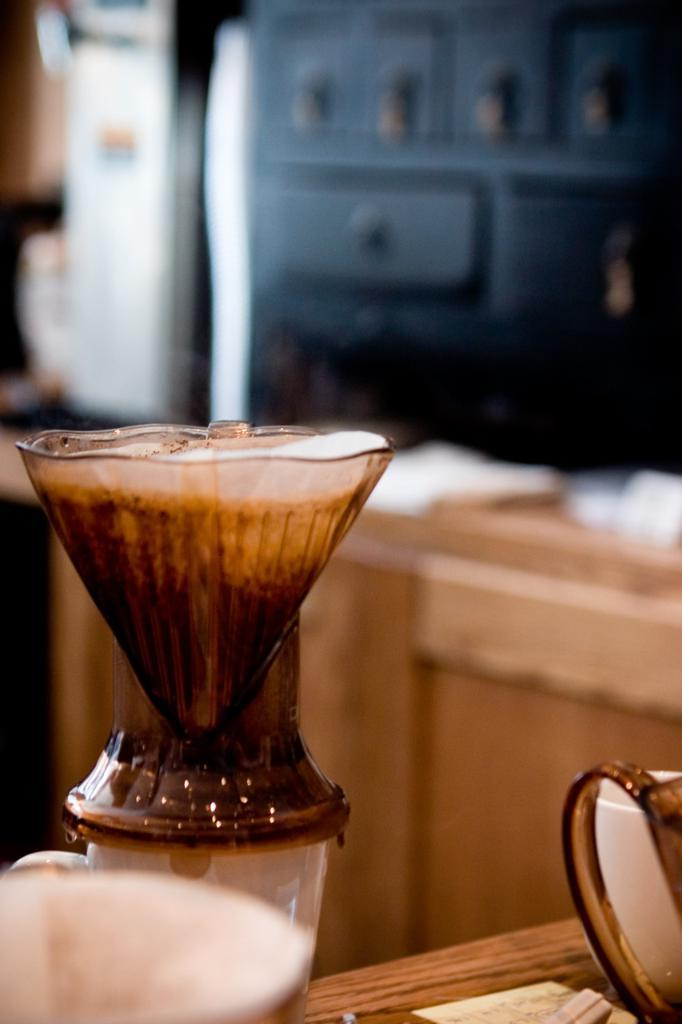What type of beverage is in the image? There is espresso in the image. Where is the espresso located in the image? The espresso is on the left side of the image. On what surface is the espresso placed? The espresso is placed on a table. Can you describe the background of the image? The background of the image is blurred. What type of breakfast is being prepared in the image? There is no breakfast preparation visible in the image; it only features espresso. Is the espresso in motion in the image? No, the espresso is not in motion in the image; it is stationary on the table. 